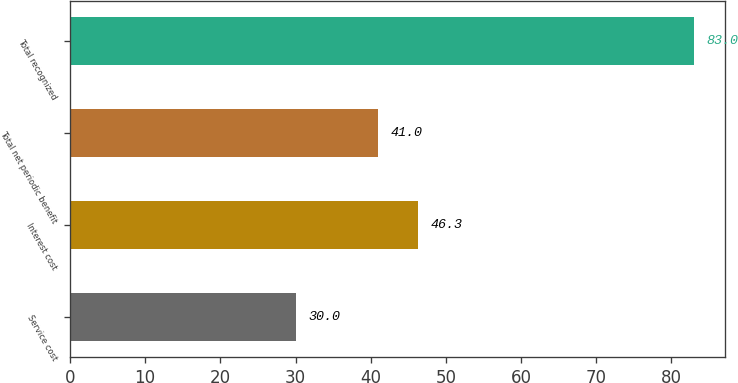Convert chart. <chart><loc_0><loc_0><loc_500><loc_500><bar_chart><fcel>Service cost<fcel>Interest cost<fcel>Total net periodic benefit<fcel>Total recognized<nl><fcel>30<fcel>46.3<fcel>41<fcel>83<nl></chart> 